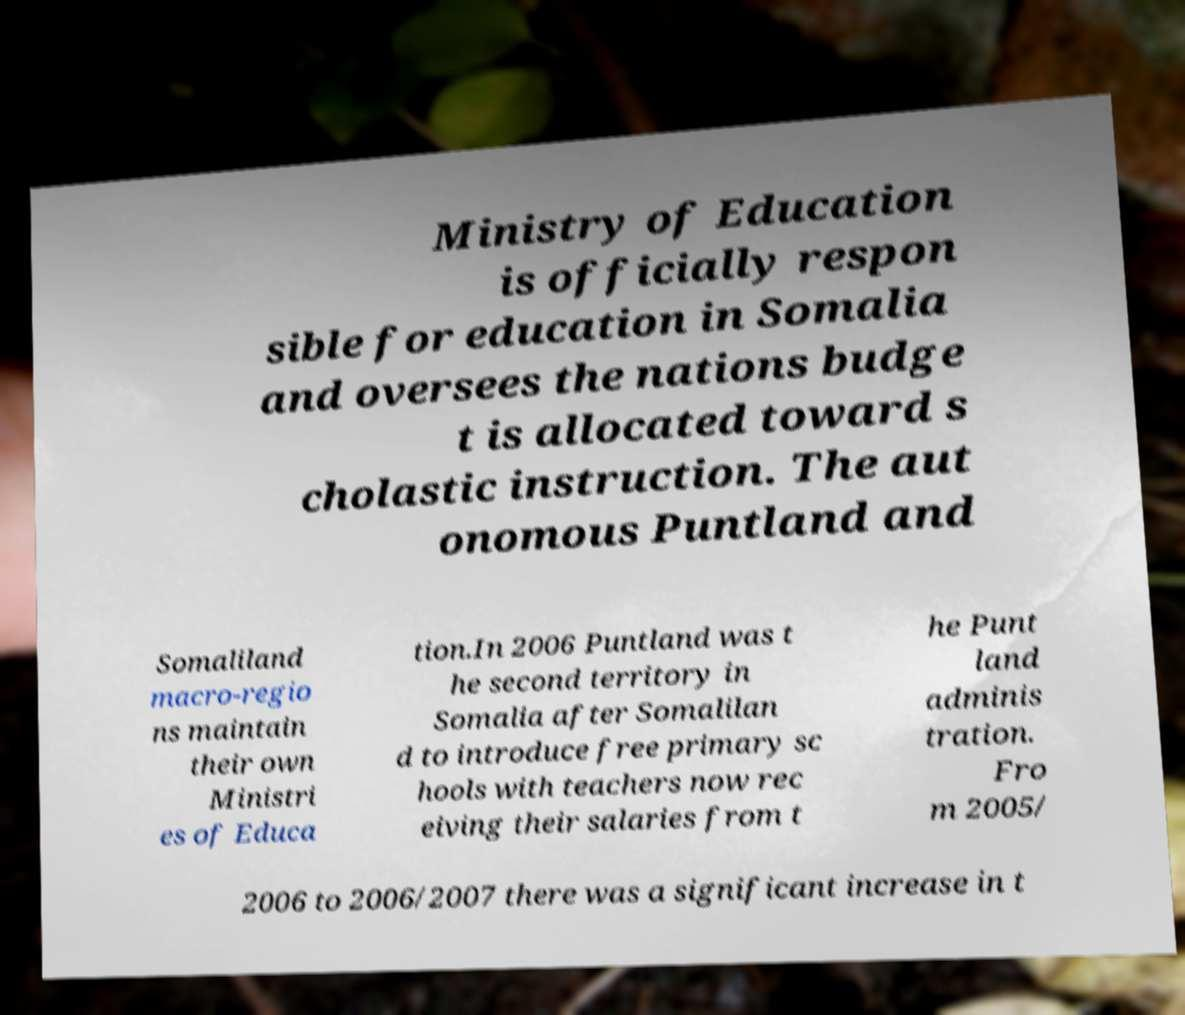What messages or text are displayed in this image? I need them in a readable, typed format. Ministry of Education is officially respon sible for education in Somalia and oversees the nations budge t is allocated toward s cholastic instruction. The aut onomous Puntland and Somaliland macro-regio ns maintain their own Ministri es of Educa tion.In 2006 Puntland was t he second territory in Somalia after Somalilan d to introduce free primary sc hools with teachers now rec eiving their salaries from t he Punt land adminis tration. Fro m 2005/ 2006 to 2006/2007 there was a significant increase in t 